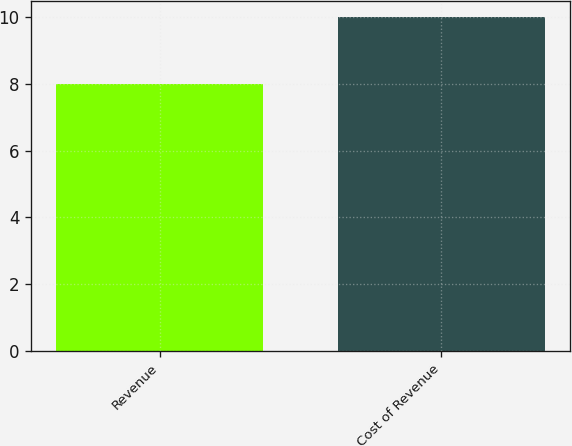<chart> <loc_0><loc_0><loc_500><loc_500><bar_chart><fcel>Revenue<fcel>Cost of Revenue<nl><fcel>8<fcel>10<nl></chart> 